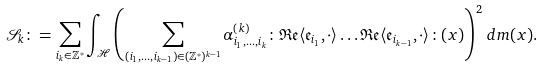<formula> <loc_0><loc_0><loc_500><loc_500>\mathcal { S } _ { k } \colon = \sum _ { i _ { k } \in \mathbb { Z } ^ { * } } \int _ { \mathcal { H } } \left ( \sum _ { ( i _ { 1 } , \dots , i _ { k - 1 } ) \in ( \mathbb { Z } ^ { * } ) ^ { k - 1 } } \alpha _ { i _ { 1 } , \dots , i _ { k } } ^ { ( k ) } \colon \mathfrak { R e } \langle \mathfrak { e } _ { i _ { 1 } } , \cdot \rangle \dots \mathfrak { R e } \langle \mathfrak { e } _ { i _ { k - 1 } } , \cdot \rangle \colon ( x ) \right ) ^ { 2 } \, d m ( x ) .</formula> 